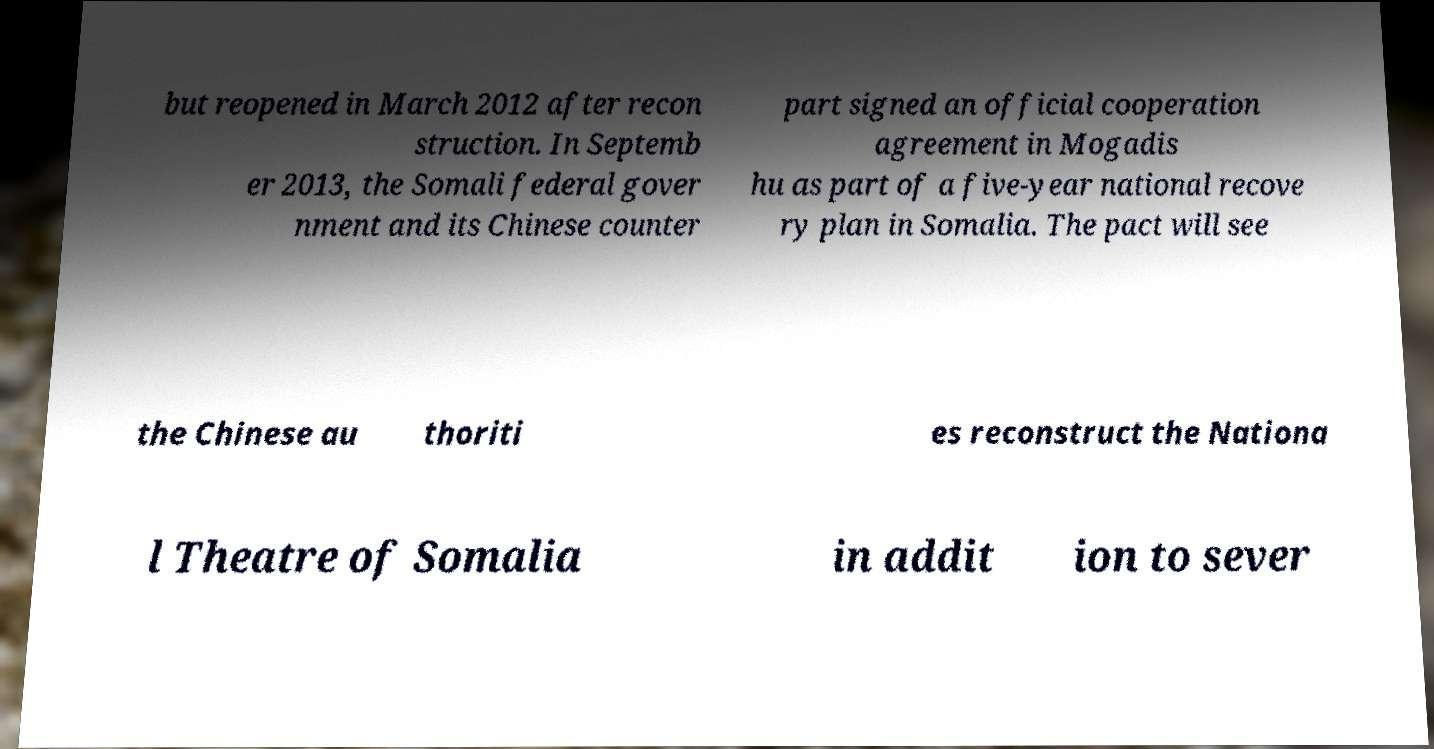I need the written content from this picture converted into text. Can you do that? but reopened in March 2012 after recon struction. In Septemb er 2013, the Somali federal gover nment and its Chinese counter part signed an official cooperation agreement in Mogadis hu as part of a five-year national recove ry plan in Somalia. The pact will see the Chinese au thoriti es reconstruct the Nationa l Theatre of Somalia in addit ion to sever 